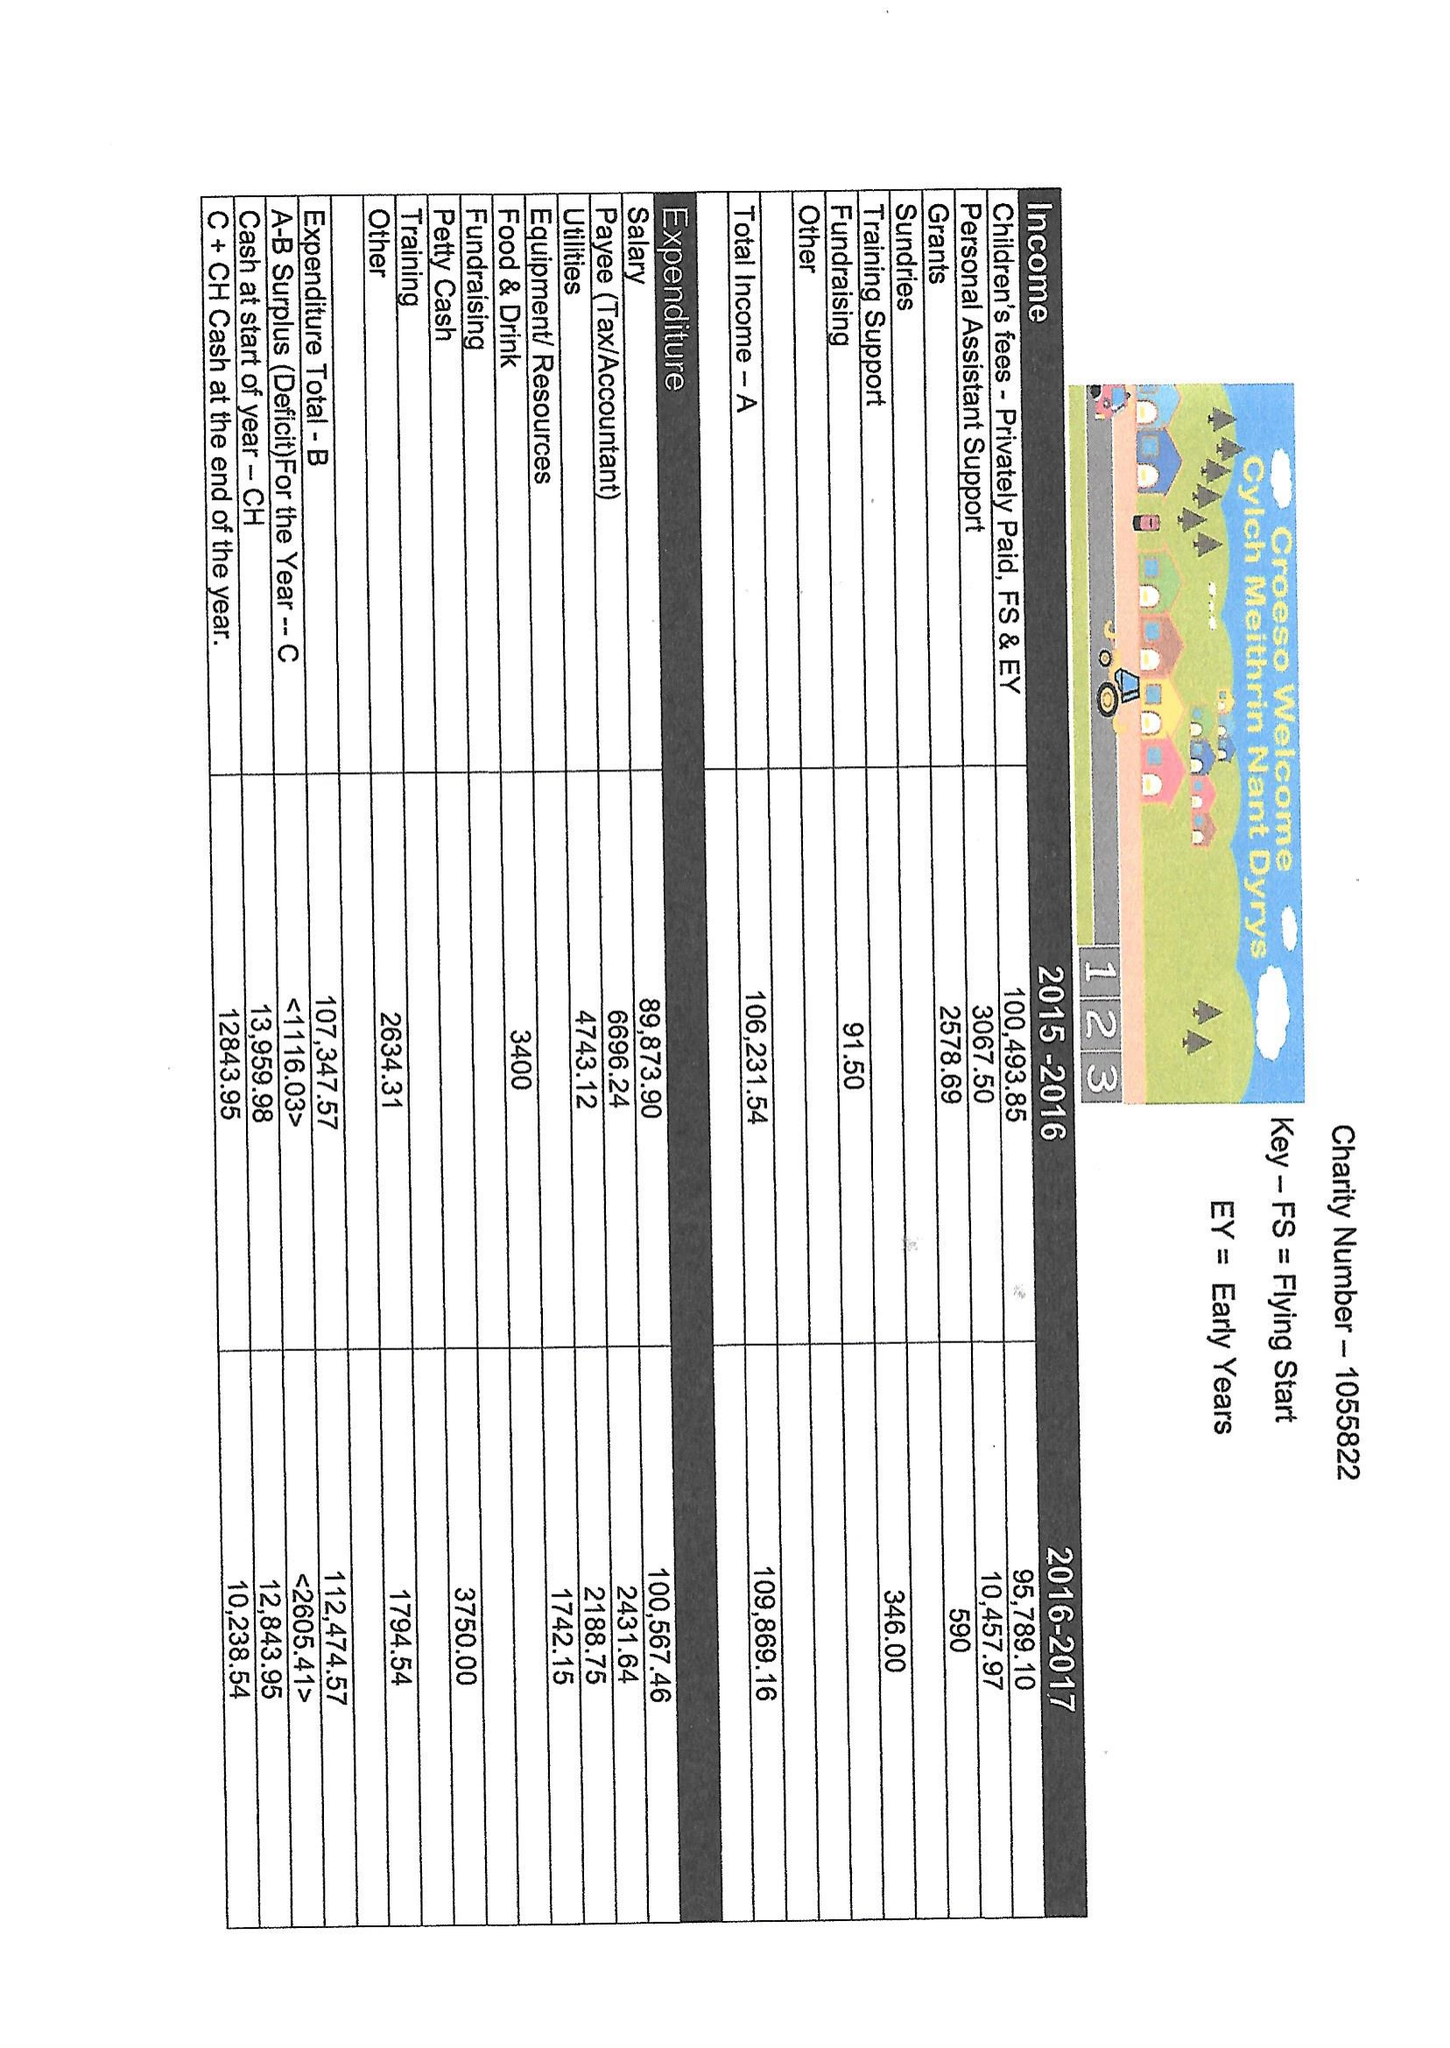What is the value for the spending_annually_in_british_pounds?
Answer the question using a single word or phrase. 112474.57 